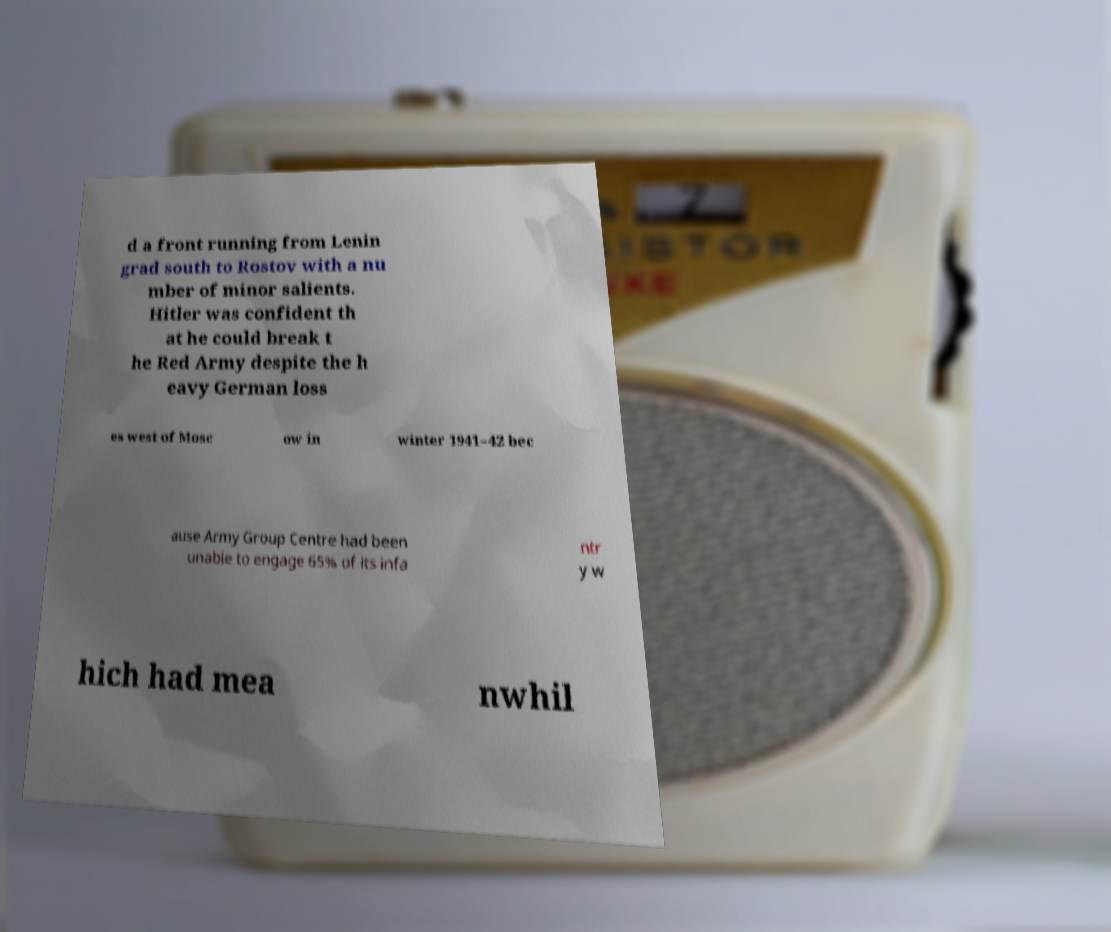Could you assist in decoding the text presented in this image and type it out clearly? d a front running from Lenin grad south to Rostov with a nu mber of minor salients. Hitler was confident th at he could break t he Red Army despite the h eavy German loss es west of Mosc ow in winter 1941–42 bec ause Army Group Centre had been unable to engage 65% of its infa ntr y w hich had mea nwhil 